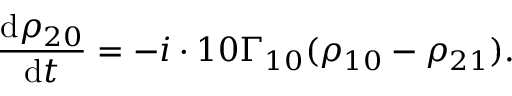Convert formula to latex. <formula><loc_0><loc_0><loc_500><loc_500>\frac { d \rho _ { 2 0 } } { d t } = - i \cdot 1 0 \Gamma _ { 1 0 } ( \rho _ { 1 0 } - \rho _ { 2 1 } ) .</formula> 